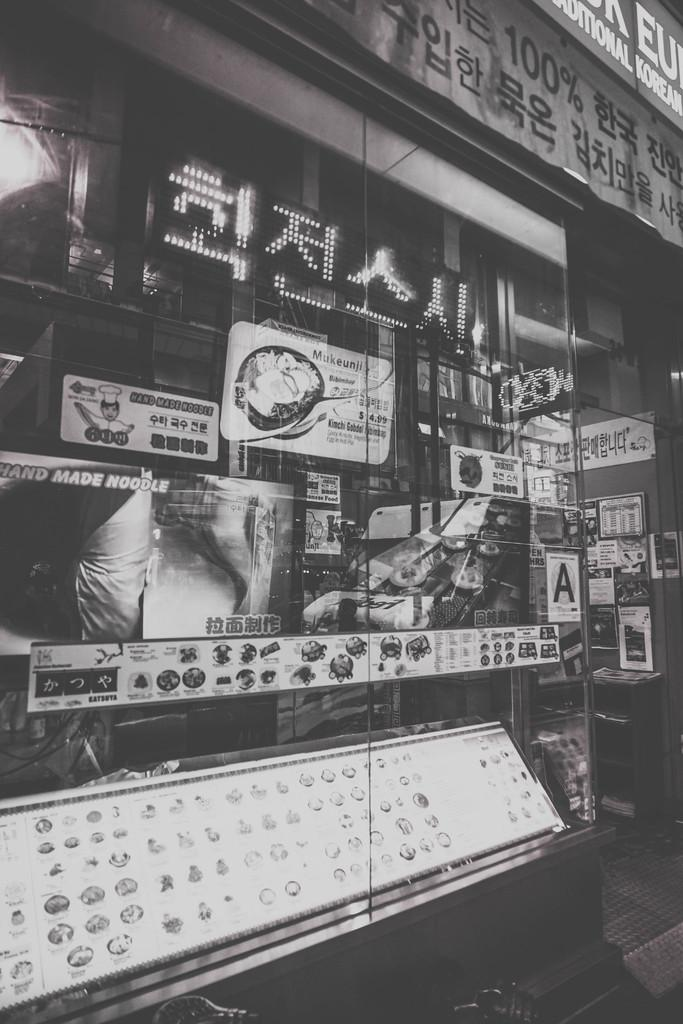What type of structure is present in the image? There is a building in the image. Can you describe any specific features of the building? There is a glass door in the building. What is located on top of the building? There is a display board on top of the building. What can be seen inside the building? There are a few items visible in the image. How is the image presented? The image is in black and white. What type of frame is holding the hose in the image? There is no hose present in the image. How many bottles are visible on the display board in the image? There are no bottles visible on the display board in the image. 